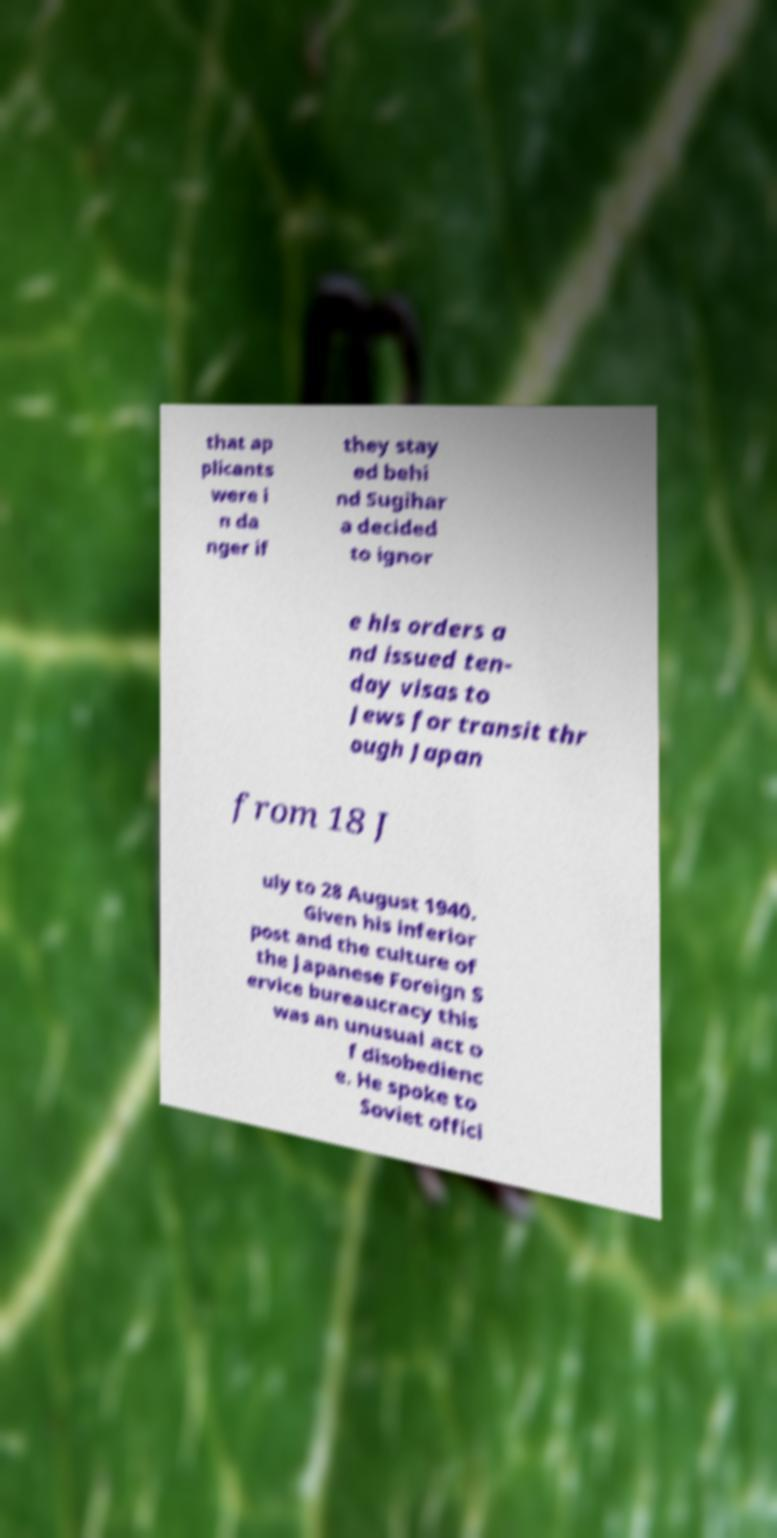What messages or text are displayed in this image? I need them in a readable, typed format. that ap plicants were i n da nger if they stay ed behi nd Sugihar a decided to ignor e his orders a nd issued ten- day visas to Jews for transit thr ough Japan from 18 J uly to 28 August 1940. Given his inferior post and the culture of the Japanese Foreign S ervice bureaucracy this was an unusual act o f disobedienc e. He spoke to Soviet offici 